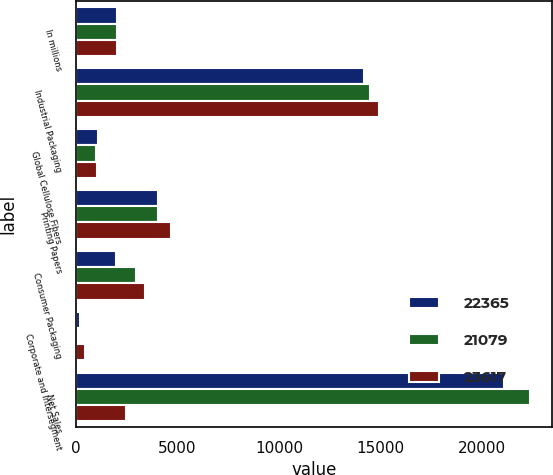<chart> <loc_0><loc_0><loc_500><loc_500><stacked_bar_chart><ecel><fcel>In millions<fcel>Industrial Packaging<fcel>Global Cellulose Fibers<fcel>Printing Papers<fcel>Consumer Packaging<fcel>Corporate and Intersegment<fcel>Net Sales<nl><fcel>22365<fcel>2016<fcel>14191<fcel>1092<fcel>4058<fcel>1954<fcel>216<fcel>21079<nl><fcel>21079<fcel>2015<fcel>14484<fcel>975<fcel>4056<fcel>2940<fcel>90<fcel>22365<nl><fcel>23617<fcel>2014<fcel>14944<fcel>1046<fcel>4674<fcel>3403<fcel>450<fcel>2478<nl></chart> 